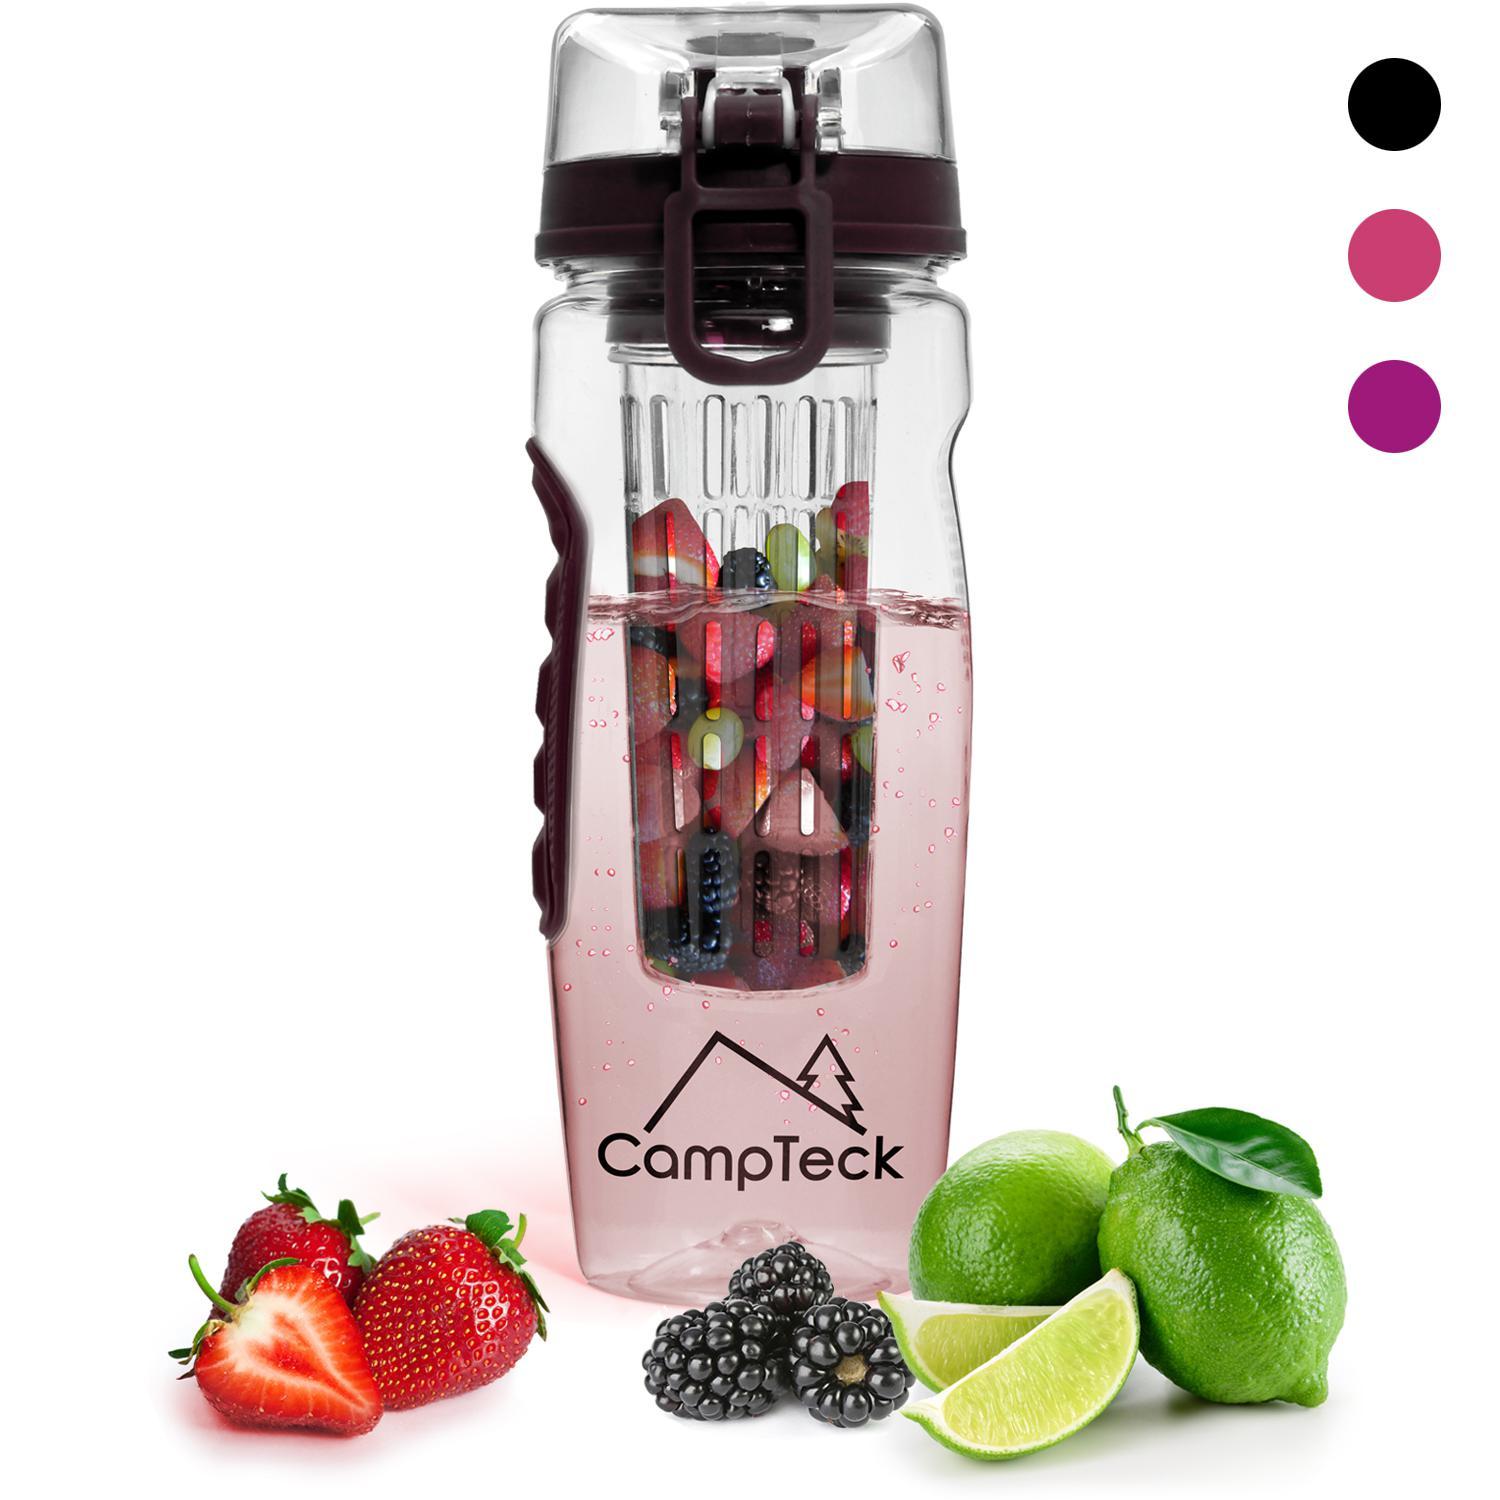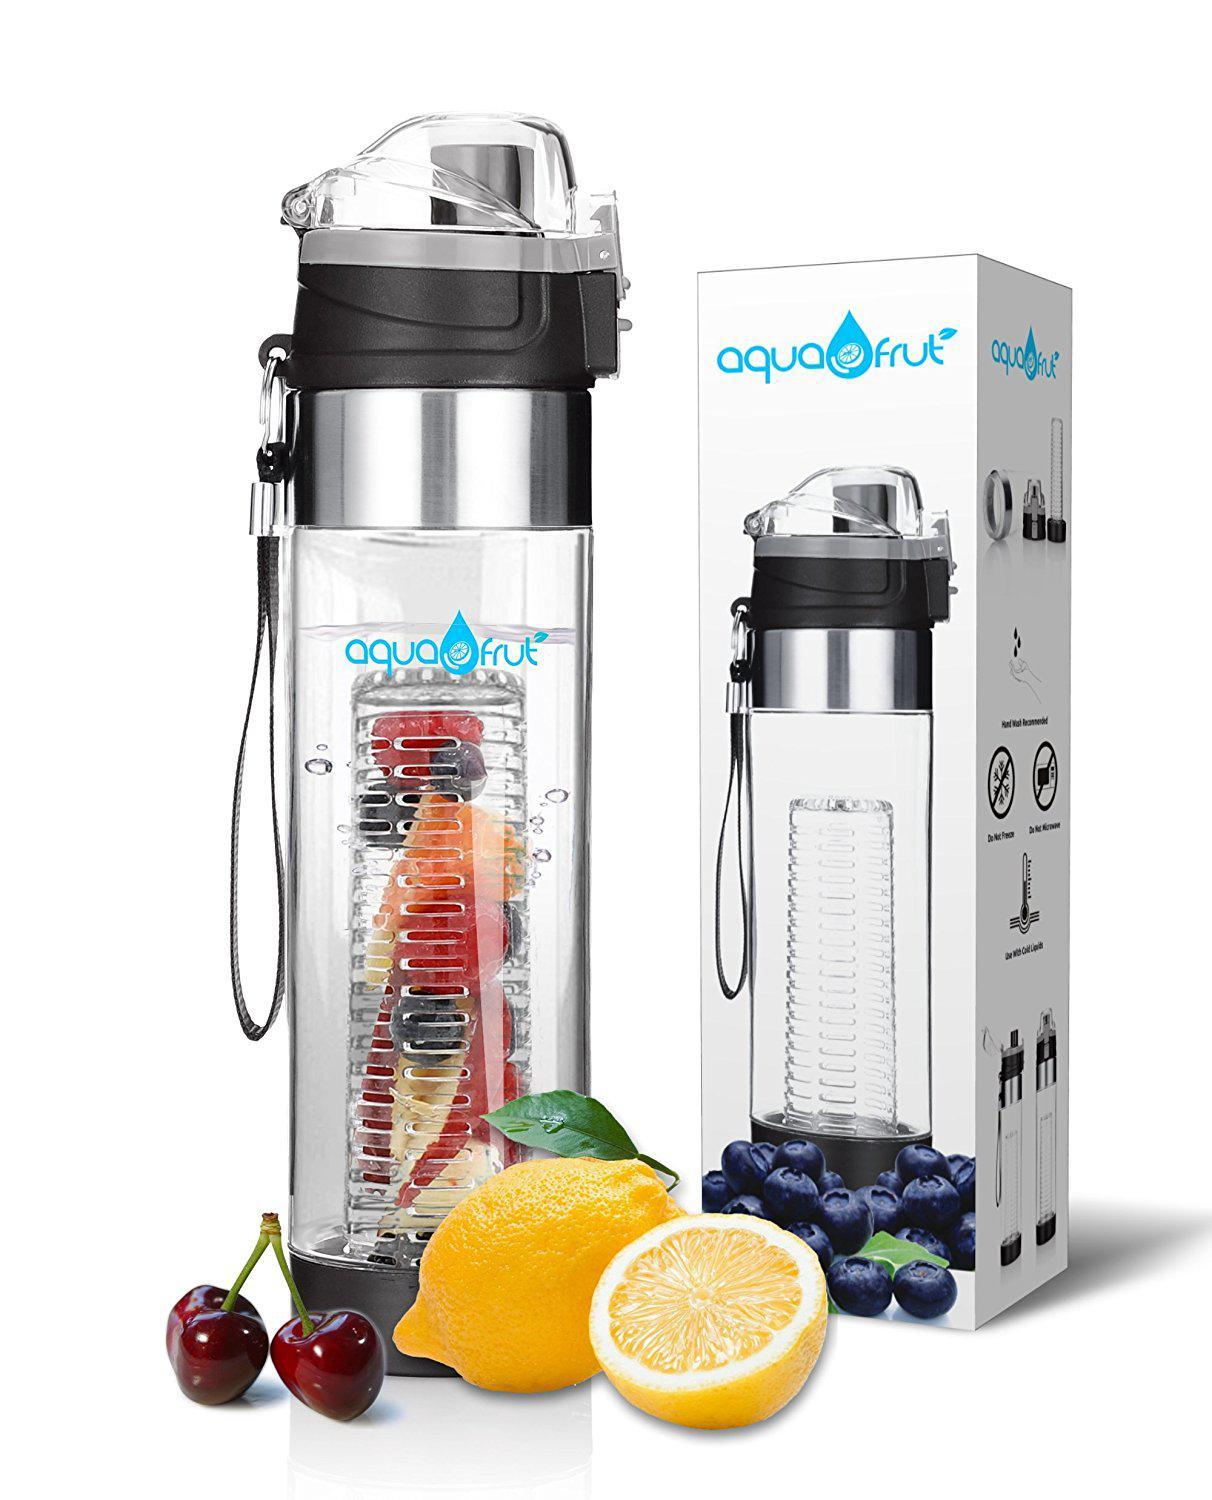The first image is the image on the left, the second image is the image on the right. For the images shown, is this caption "An image shows three water bottles posed next to fruits." true? Answer yes or no. No. The first image is the image on the left, the second image is the image on the right. Considering the images on both sides, is "Three clear containers stand in a line in one of the images." valid? Answer yes or no. No. 